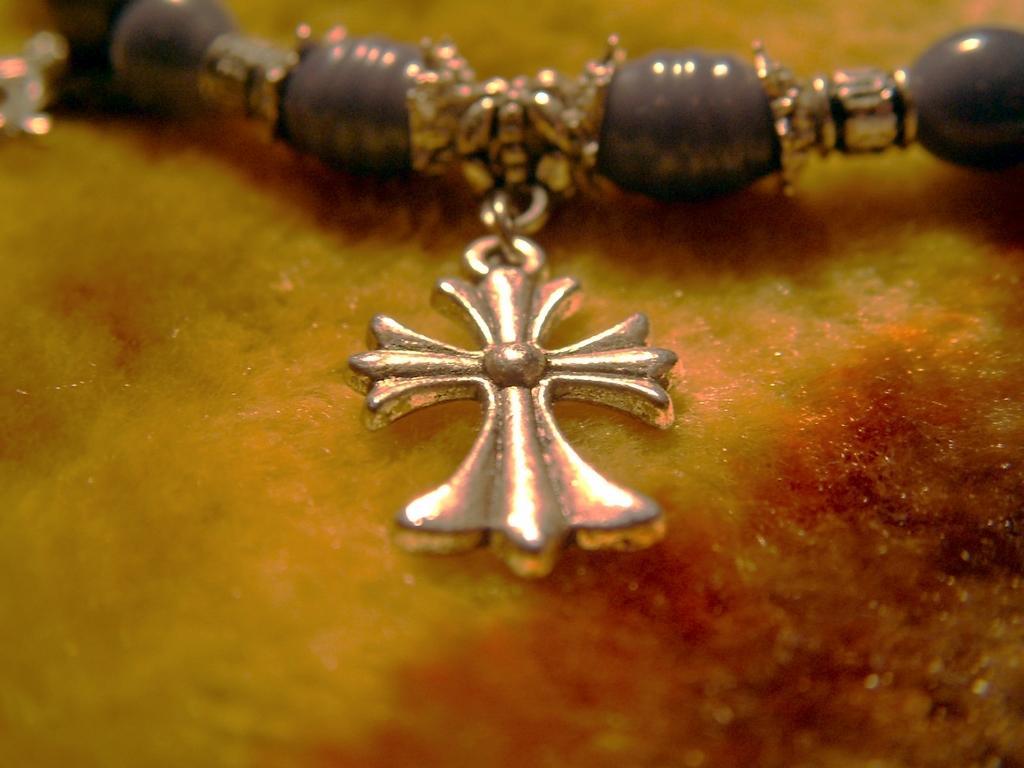Describe this image in one or two sentences. In the center of the image we can see chain. 